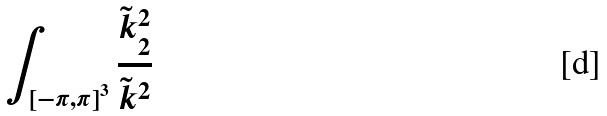Convert formula to latex. <formula><loc_0><loc_0><loc_500><loc_500>\int _ { \left [ - \pi , \pi \right ] ^ { 3 } } \frac { \tilde { k } _ { 2 } ^ { 2 } } { \tilde { k } ^ { 2 } }</formula> 